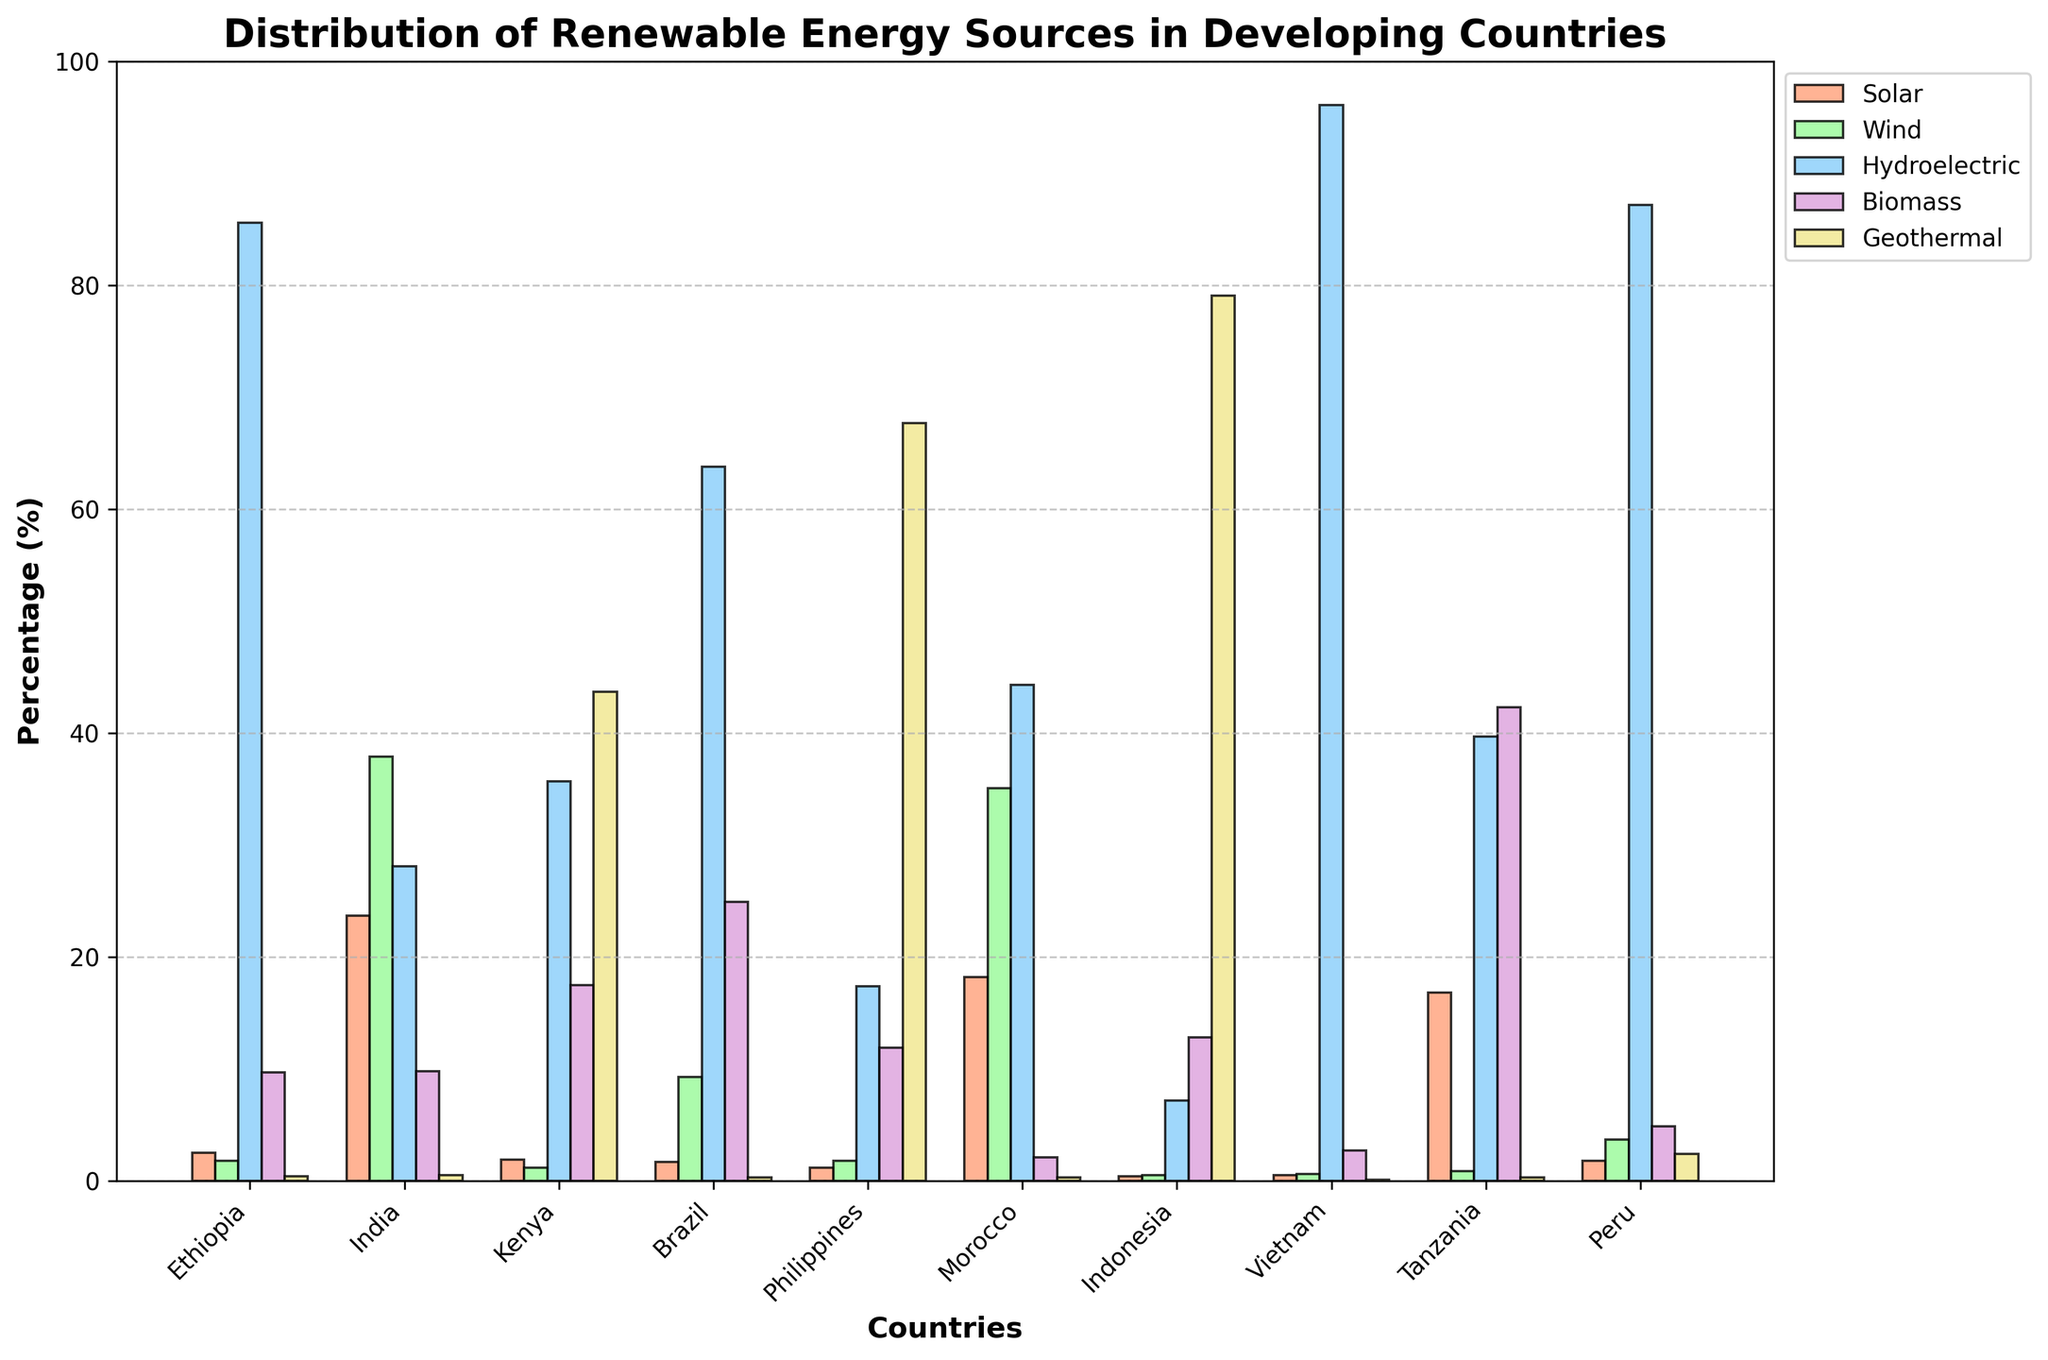Which country has the highest percentage of wind energy? To find the country with the highest percentage of wind energy, look at the heights of the green-colored bars (representing wind energy) for each country. The tallest green bar corresponds to India at 37.9%.
Answer: India What is the combined percentage of solar and wind energy in Morocco? First, locate the bars for solar (orange) and wind energy (green) for Morocco. The solar energy bar is at 18.2% and the wind energy bar is at 35.1%. Summing these values, 18.2% + 35.1% = 53.3%.
Answer: 53.3% Which country relies the most on geothermal energy? The bars representing geothermal energy are colored in yellow. The tallest yellow bar can be found for the Philippines, indicating the highest reliance at 67.7%.
Answer: Philippines How does the biomass energy percentage in Brazil compare to that in Tanzania? To compare, look at the purple bars for biomass energy for both countries. Brazil's bar is at 24.9%, while Tanzania's bar is at 42.3%. Tanzania's percentage is higher.
Answer: Tanzania What is the average percentage of hydroelectric energy across all countries? Add the percentages labeled as hydroelectric for each country and then divide by the number of countries. (85.6 + 28.1 + 35.7 + 63.8 + 17.4 + 44.3 + 7.2 + 96.1 + 39.7 + 87.2) / 10 = 50.81%
Answer: 50.81% Which two countries have the closest percentages for biomass energy? Compare the purple bars representing biomass energy. The closest values are for Ethiopia at 9.7% and India at 9.8%, which differ by only 0.1%.
Answer: Ethiopia and India Between Kenya and Indonesia, which country has a higher percentage of total renewable energy? Sum the percentages of all five energy sources for Kenya and Indonesia. Kenya: 1.9% + 1.2% + 35.7% + 17.5% + 43.7% = 100%. Indonesia: 0.4% + 0.5% + 7.2% + 12.8% + 79.1% = 100%. Both are 100%, so they are equal.
Answer: Equal 